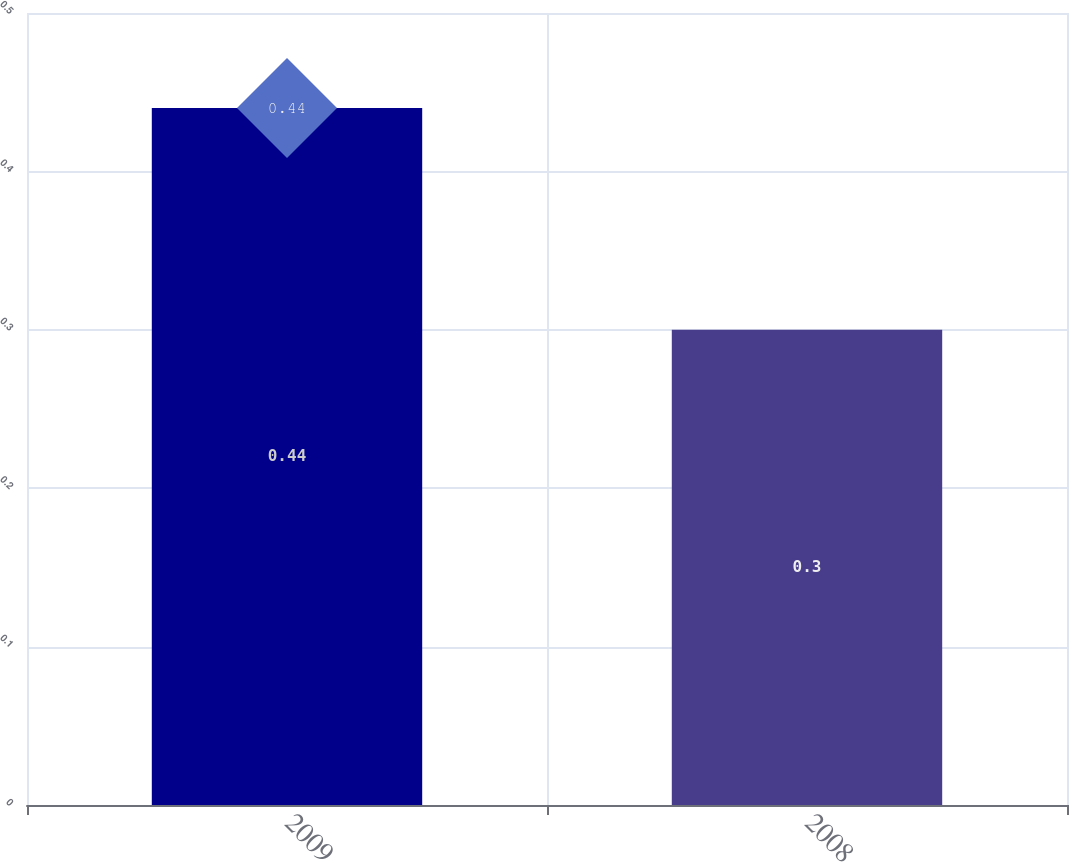Convert chart. <chart><loc_0><loc_0><loc_500><loc_500><bar_chart><fcel>2009<fcel>2008<nl><fcel>0.44<fcel>0.3<nl></chart> 